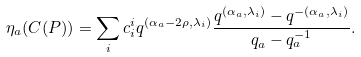Convert formula to latex. <formula><loc_0><loc_0><loc_500><loc_500>\eta _ { a } ( C ( P ) ) = \sum _ { i } c _ { i } ^ { i } q ^ { ( \alpha _ { a } - 2 \rho , \lambda _ { i } ) } \frac { q ^ { ( \alpha _ { a } , \lambda _ { i } ) } - q ^ { - ( \alpha _ { a } , \lambda _ { i } ) } } { q _ { a } - q _ { a } ^ { - 1 } } .</formula> 